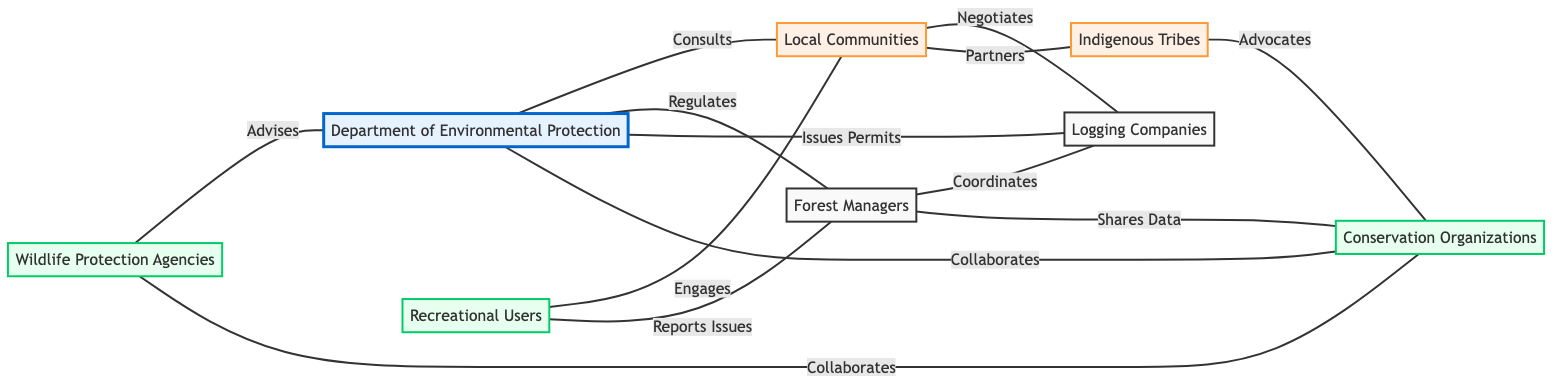What is the total number of stakeholders represented in the graph? The diagram lists a total of 8 stakeholders: Department of Environmental Protection, Local Communities, Forest Managers, Logging Companies, Conservation Organizations, Indigenous Tribes, Recreational Users, and Wildlife Protection Agencies.
Answer: 8 Which entity collaborates with Conservation Organizations? Conservation Organizations have collaborations with three entities: Department of Environmental Protection, Indigenous Tribes, and Wildlife Protection Agencies. Focusing on the partnerships, the first entity is mentioned directly in the relationship labeled "Collaborates."
Answer: Department of Environmental Protection, Indigenous Tribes, Wildlife Protection Agencies How many edges are there from Local Communities to other stakeholders? From the diagram, Local Communities connect with Logging Companies (Negotiates) and Indigenous Tribes (Partners). Therefore, there are 2 connections.
Answer: 2 Which entity issues permits to Logging Companies? The Department of Environmental Protection is the entity responsible for issuing permits to Logging Companies as indicated by the edge labeled "Issues Permits."
Answer: Department of Environmental Protection What type of relationship exists between Recreational Users and Local Communities? The graph shows that Recreational Users engage with Local Communities, as indicated by the edge labeled "Engages."
Answer: Engages Which two stakeholders share data with Forest Managers? Forest Managers share data with Conservation Organizations and also coordinate with Logging Companies. The edge labeled "Shares Data" denotes this interaction with Conservation Organizations.
Answer: Logging Companies, Conservation Organizations Do Indigenous Tribes advocate for any agency? Yes, the diagram illustrates that Indigenous Tribes advocate for Conservation Organizations as shown by the edge labeled "Advocates."
Answer: Conservation Organizations How many total relationships does the Department of Environmental Protection have with other stakeholders? The Department of Environmental Protection has four relationships with stakeholders: Consults (Local Communities), Regulates (Forest Managers), Issues Permits (Logging Companies), and Collaborates (Conservation Organizations), resulting in 4 total edges.
Answer: 4 